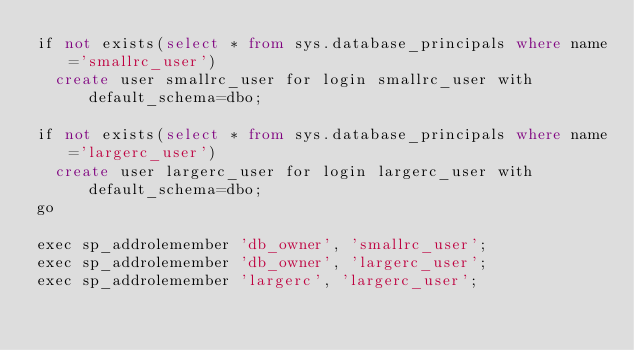Convert code to text. <code><loc_0><loc_0><loc_500><loc_500><_SQL_>if not exists(select * from sys.database_principals where name='smallrc_user')
	create user smallrc_user for login smallrc_user with default_schema=dbo;

if not exists(select * from sys.database_principals where name='largerc_user')
	create user largerc_user for login largerc_user with default_schema=dbo;
go

exec sp_addrolemember 'db_owner', 'smallrc_user';
exec sp_addrolemember 'db_owner', 'largerc_user';
exec sp_addrolemember 'largerc', 'largerc_user';
</code> 